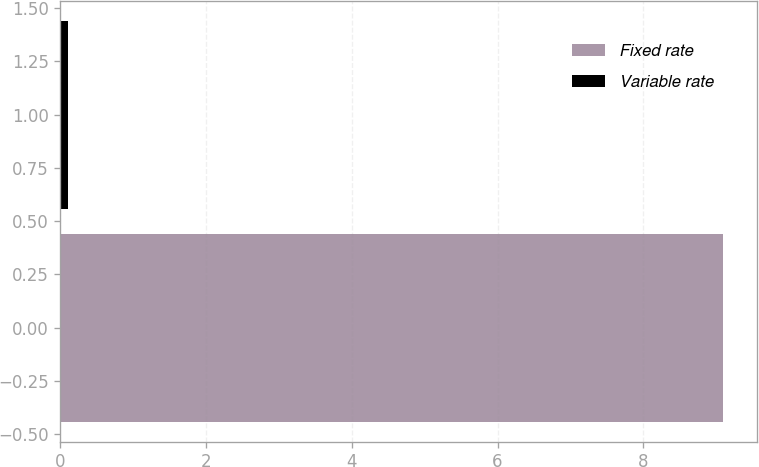Convert chart. <chart><loc_0><loc_0><loc_500><loc_500><bar_chart><fcel>Fixed rate<fcel>Variable rate<nl><fcel>9.1<fcel>0.1<nl></chart> 